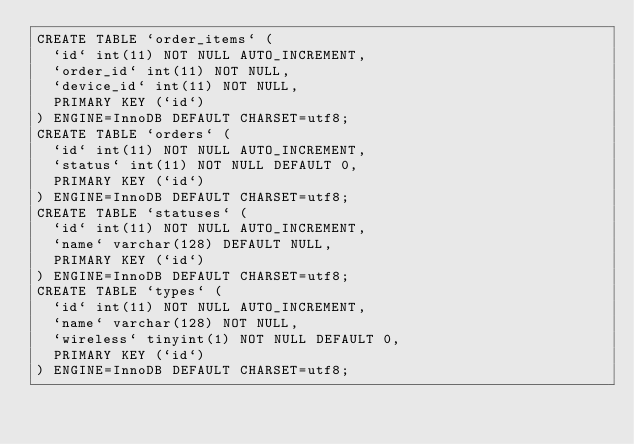<code> <loc_0><loc_0><loc_500><loc_500><_SQL_>CREATE TABLE `order_items` (
  `id` int(11) NOT NULL AUTO_INCREMENT,
  `order_id` int(11) NOT NULL,
  `device_id` int(11) NOT NULL,
  PRIMARY KEY (`id`)
) ENGINE=InnoDB DEFAULT CHARSET=utf8;
CREATE TABLE `orders` (
  `id` int(11) NOT NULL AUTO_INCREMENT,
  `status` int(11) NOT NULL DEFAULT 0,
  PRIMARY KEY (`id`)
) ENGINE=InnoDB DEFAULT CHARSET=utf8;
CREATE TABLE `statuses` (
  `id` int(11) NOT NULL AUTO_INCREMENT,
  `name` varchar(128) DEFAULT NULL,
  PRIMARY KEY (`id`)
) ENGINE=InnoDB DEFAULT CHARSET=utf8;
CREATE TABLE `types` (
  `id` int(11) NOT NULL AUTO_INCREMENT,
  `name` varchar(128) NOT NULL,
  `wireless` tinyint(1) NOT NULL DEFAULT 0,
  PRIMARY KEY (`id`)
) ENGINE=InnoDB DEFAULT CHARSET=utf8;
</code> 